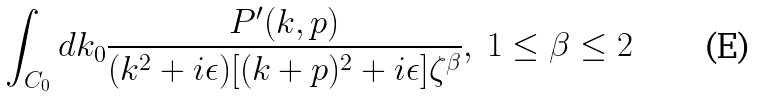Convert formula to latex. <formula><loc_0><loc_0><loc_500><loc_500>\int _ { C _ { 0 } } d k _ { 0 } { \frac { P ^ { \prime } ( k , p ) } { ( k ^ { 2 } + i \epsilon ) [ ( k + p ) ^ { 2 } + i \epsilon ] \zeta ^ { \beta } } } , \ 1 \leq \beta \leq 2</formula> 